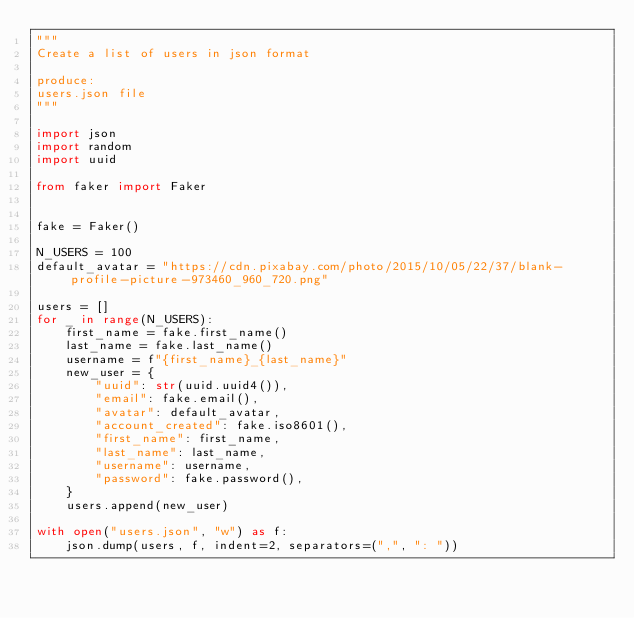Convert code to text. <code><loc_0><loc_0><loc_500><loc_500><_Python_>"""
Create a list of users in json format

produce:
users.json file
"""

import json
import random
import uuid

from faker import Faker


fake = Faker()

N_USERS = 100
default_avatar = "https://cdn.pixabay.com/photo/2015/10/05/22/37/blank-profile-picture-973460_960_720.png"

users = []
for _ in range(N_USERS):
    first_name = fake.first_name()
    last_name = fake.last_name()
    username = f"{first_name}_{last_name}"
    new_user = {
        "uuid": str(uuid.uuid4()),
        "email": fake.email(),
        "avatar": default_avatar,
        "account_created": fake.iso8601(),
        "first_name": first_name,
        "last_name": last_name,
        "username": username,
        "password": fake.password(),
    }
    users.append(new_user)

with open("users.json", "w") as f:
    json.dump(users, f, indent=2, separators=(",", ": "))
</code> 